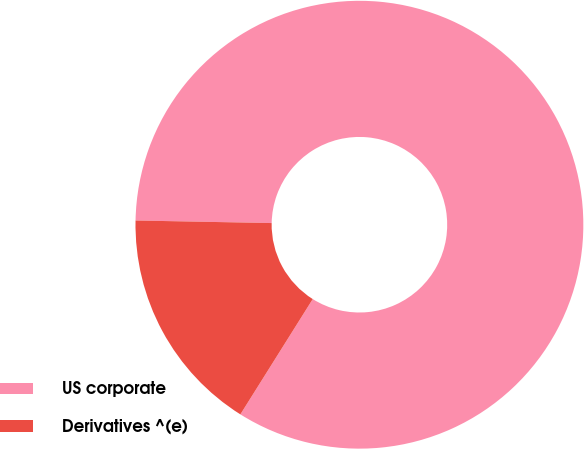<chart> <loc_0><loc_0><loc_500><loc_500><pie_chart><fcel>US corporate<fcel>Derivatives ^(e)<nl><fcel>83.62%<fcel>16.38%<nl></chart> 